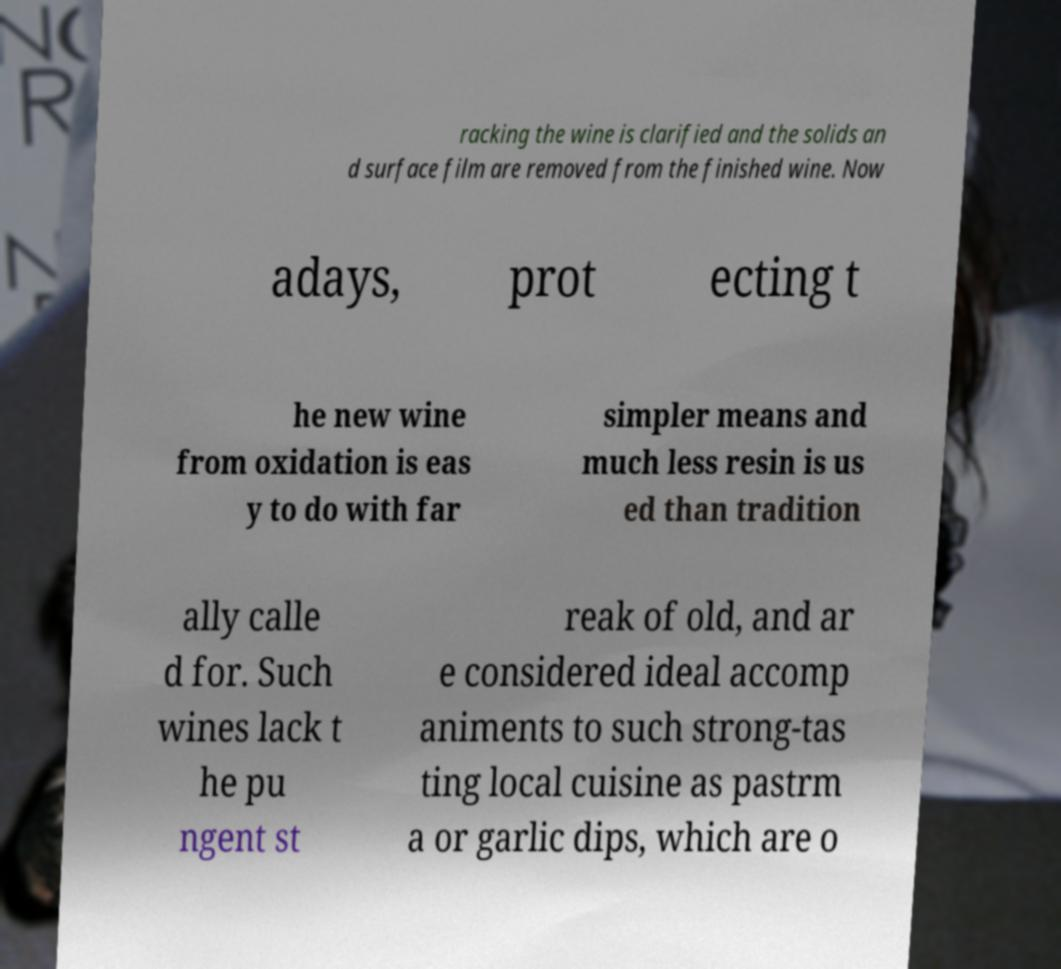There's text embedded in this image that I need extracted. Can you transcribe it verbatim? racking the wine is clarified and the solids an d surface film are removed from the finished wine. Now adays, prot ecting t he new wine from oxidation is eas y to do with far simpler means and much less resin is us ed than tradition ally calle d for. Such wines lack t he pu ngent st reak of old, and ar e considered ideal accomp animents to such strong-tas ting local cuisine as pastrm a or garlic dips, which are o 